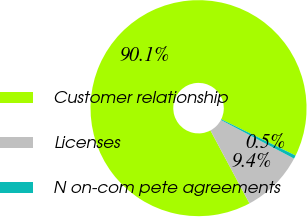Convert chart to OTSL. <chart><loc_0><loc_0><loc_500><loc_500><pie_chart><fcel>Customer relationship<fcel>Licenses<fcel>N on-com pete agreements<nl><fcel>90.05%<fcel>9.45%<fcel>0.5%<nl></chart> 